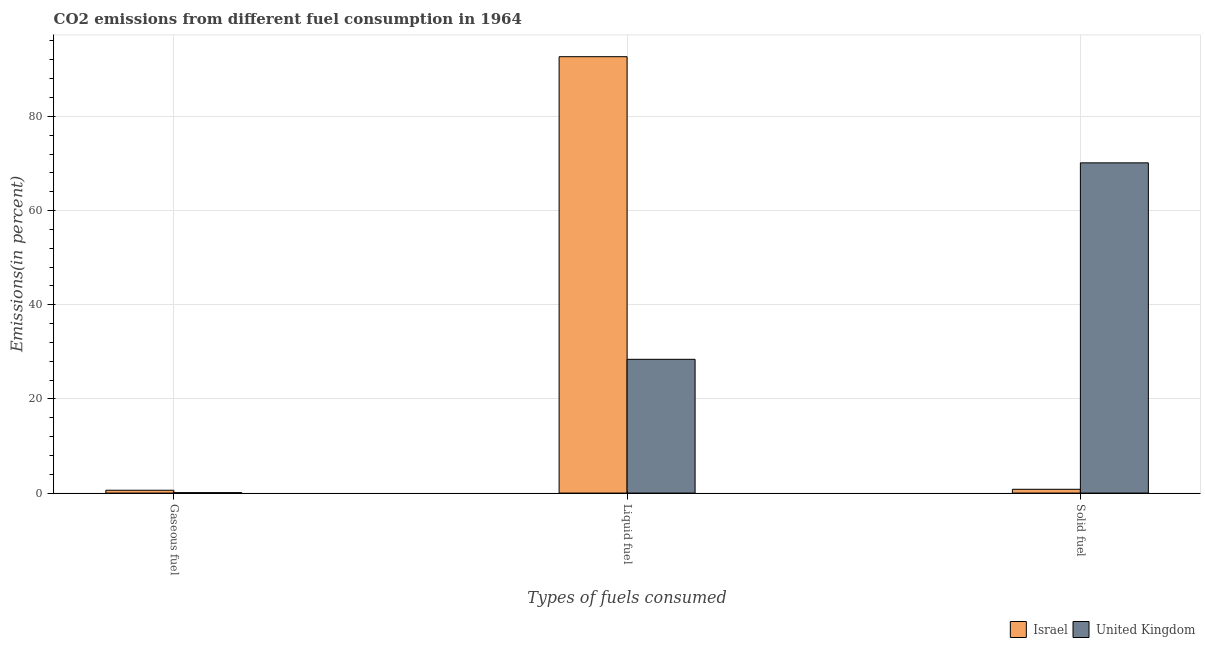How many different coloured bars are there?
Your response must be concise. 2. How many groups of bars are there?
Keep it short and to the point. 3. How many bars are there on the 2nd tick from the left?
Make the answer very short. 2. How many bars are there on the 2nd tick from the right?
Provide a short and direct response. 2. What is the label of the 1st group of bars from the left?
Offer a terse response. Gaseous fuel. What is the percentage of gaseous fuel emission in Israel?
Keep it short and to the point. 0.6. Across all countries, what is the maximum percentage of liquid fuel emission?
Your response must be concise. 92.67. Across all countries, what is the minimum percentage of liquid fuel emission?
Your answer should be very brief. 28.4. In which country was the percentage of liquid fuel emission maximum?
Your answer should be compact. Israel. In which country was the percentage of liquid fuel emission minimum?
Make the answer very short. United Kingdom. What is the total percentage of gaseous fuel emission in the graph?
Give a very brief answer. 0.69. What is the difference between the percentage of gaseous fuel emission in Israel and that in United Kingdom?
Your answer should be compact. 0.52. What is the difference between the percentage of gaseous fuel emission in Israel and the percentage of liquid fuel emission in United Kingdom?
Ensure brevity in your answer.  -27.8. What is the average percentage of liquid fuel emission per country?
Offer a very short reply. 60.53. What is the difference between the percentage of gaseous fuel emission and percentage of solid fuel emission in Israel?
Your answer should be very brief. -0.2. In how many countries, is the percentage of liquid fuel emission greater than 64 %?
Make the answer very short. 1. What is the ratio of the percentage of gaseous fuel emission in Israel to that in United Kingdom?
Provide a short and direct response. 7.12. Is the difference between the percentage of solid fuel emission in Israel and United Kingdom greater than the difference between the percentage of gaseous fuel emission in Israel and United Kingdom?
Give a very brief answer. No. What is the difference between the highest and the second highest percentage of gaseous fuel emission?
Make the answer very short. 0.52. What is the difference between the highest and the lowest percentage of gaseous fuel emission?
Provide a short and direct response. 0.52. In how many countries, is the percentage of solid fuel emission greater than the average percentage of solid fuel emission taken over all countries?
Provide a short and direct response. 1. Is the sum of the percentage of liquid fuel emission in Israel and United Kingdom greater than the maximum percentage of gaseous fuel emission across all countries?
Offer a very short reply. Yes. Is it the case that in every country, the sum of the percentage of gaseous fuel emission and percentage of liquid fuel emission is greater than the percentage of solid fuel emission?
Your answer should be compact. No. How many bars are there?
Make the answer very short. 6. Are the values on the major ticks of Y-axis written in scientific E-notation?
Keep it short and to the point. No. Where does the legend appear in the graph?
Your response must be concise. Bottom right. How many legend labels are there?
Provide a succinct answer. 2. How are the legend labels stacked?
Keep it short and to the point. Horizontal. What is the title of the graph?
Ensure brevity in your answer.  CO2 emissions from different fuel consumption in 1964. What is the label or title of the X-axis?
Offer a very short reply. Types of fuels consumed. What is the label or title of the Y-axis?
Provide a short and direct response. Emissions(in percent). What is the Emissions(in percent) of Israel in Gaseous fuel?
Offer a terse response. 0.6. What is the Emissions(in percent) of United Kingdom in Gaseous fuel?
Your response must be concise. 0.08. What is the Emissions(in percent) of Israel in Liquid fuel?
Your response must be concise. 92.67. What is the Emissions(in percent) in United Kingdom in Liquid fuel?
Give a very brief answer. 28.4. What is the Emissions(in percent) of Israel in Solid fuel?
Your answer should be compact. 0.8. What is the Emissions(in percent) of United Kingdom in Solid fuel?
Your answer should be compact. 70.12. Across all Types of fuels consumed, what is the maximum Emissions(in percent) of Israel?
Your answer should be very brief. 92.67. Across all Types of fuels consumed, what is the maximum Emissions(in percent) in United Kingdom?
Provide a succinct answer. 70.12. Across all Types of fuels consumed, what is the minimum Emissions(in percent) of Israel?
Give a very brief answer. 0.6. Across all Types of fuels consumed, what is the minimum Emissions(in percent) of United Kingdom?
Make the answer very short. 0.08. What is the total Emissions(in percent) of Israel in the graph?
Offer a very short reply. 94.07. What is the total Emissions(in percent) of United Kingdom in the graph?
Offer a terse response. 98.61. What is the difference between the Emissions(in percent) of Israel in Gaseous fuel and that in Liquid fuel?
Your response must be concise. -92.06. What is the difference between the Emissions(in percent) of United Kingdom in Gaseous fuel and that in Liquid fuel?
Provide a short and direct response. -28.32. What is the difference between the Emissions(in percent) of Israel in Gaseous fuel and that in Solid fuel?
Your answer should be very brief. -0.2. What is the difference between the Emissions(in percent) in United Kingdom in Gaseous fuel and that in Solid fuel?
Provide a short and direct response. -70.04. What is the difference between the Emissions(in percent) in Israel in Liquid fuel and that in Solid fuel?
Your response must be concise. 91.86. What is the difference between the Emissions(in percent) in United Kingdom in Liquid fuel and that in Solid fuel?
Your answer should be compact. -41.72. What is the difference between the Emissions(in percent) in Israel in Gaseous fuel and the Emissions(in percent) in United Kingdom in Liquid fuel?
Ensure brevity in your answer.  -27.8. What is the difference between the Emissions(in percent) in Israel in Gaseous fuel and the Emissions(in percent) in United Kingdom in Solid fuel?
Provide a short and direct response. -69.52. What is the difference between the Emissions(in percent) of Israel in Liquid fuel and the Emissions(in percent) of United Kingdom in Solid fuel?
Provide a succinct answer. 22.54. What is the average Emissions(in percent) of Israel per Types of fuels consumed?
Your response must be concise. 31.36. What is the average Emissions(in percent) in United Kingdom per Types of fuels consumed?
Provide a succinct answer. 32.87. What is the difference between the Emissions(in percent) of Israel and Emissions(in percent) of United Kingdom in Gaseous fuel?
Provide a short and direct response. 0.52. What is the difference between the Emissions(in percent) of Israel and Emissions(in percent) of United Kingdom in Liquid fuel?
Make the answer very short. 64.26. What is the difference between the Emissions(in percent) of Israel and Emissions(in percent) of United Kingdom in Solid fuel?
Make the answer very short. -69.32. What is the ratio of the Emissions(in percent) of Israel in Gaseous fuel to that in Liquid fuel?
Keep it short and to the point. 0.01. What is the ratio of the Emissions(in percent) of United Kingdom in Gaseous fuel to that in Liquid fuel?
Your response must be concise. 0. What is the ratio of the Emissions(in percent) in United Kingdom in Gaseous fuel to that in Solid fuel?
Your answer should be very brief. 0. What is the ratio of the Emissions(in percent) in Israel in Liquid fuel to that in Solid fuel?
Provide a succinct answer. 115.6. What is the ratio of the Emissions(in percent) of United Kingdom in Liquid fuel to that in Solid fuel?
Offer a very short reply. 0.41. What is the difference between the highest and the second highest Emissions(in percent) in Israel?
Offer a very short reply. 91.86. What is the difference between the highest and the second highest Emissions(in percent) in United Kingdom?
Offer a terse response. 41.72. What is the difference between the highest and the lowest Emissions(in percent) in Israel?
Keep it short and to the point. 92.06. What is the difference between the highest and the lowest Emissions(in percent) in United Kingdom?
Your response must be concise. 70.04. 